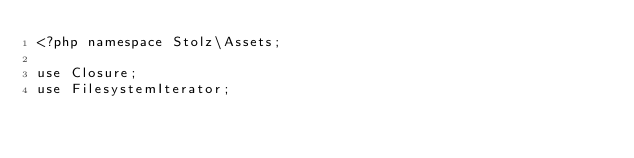Convert code to text. <code><loc_0><loc_0><loc_500><loc_500><_PHP_><?php namespace Stolz\Assets;

use Closure;
use FilesystemIterator;</code> 